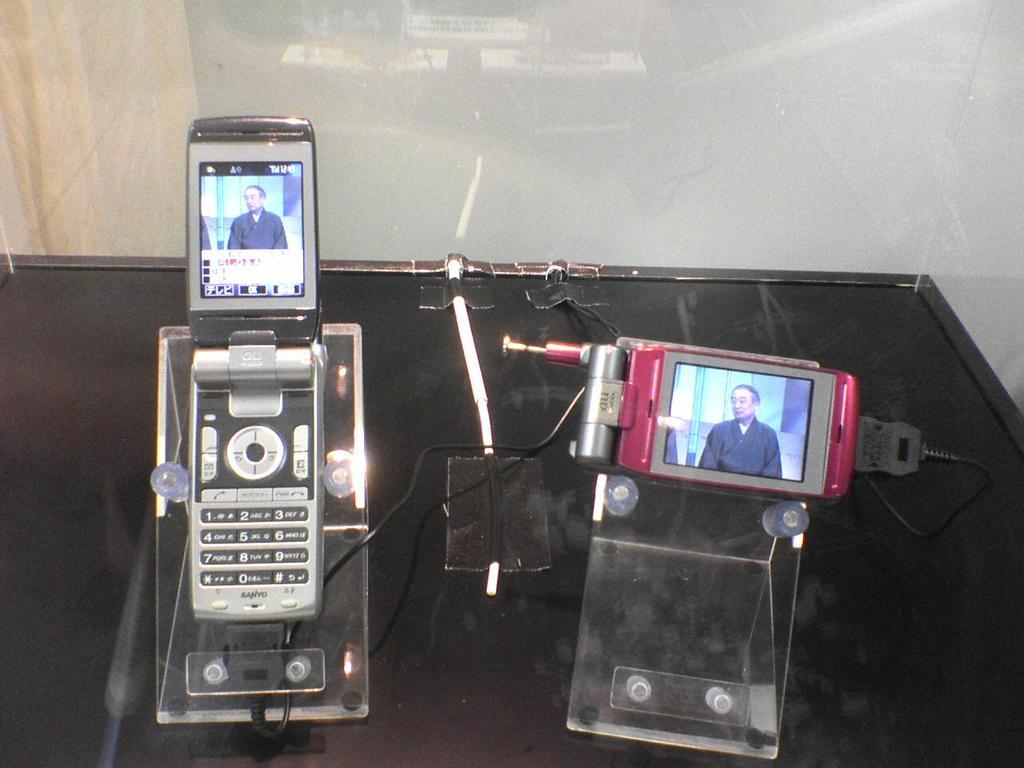What objects can be seen in the image? There are mobiles, stands, and cables on the table in the image. What is the purpose of the stands in the image? The purpose of the stands is not explicitly stated, but they may be used to support or display the mobiles. What is the appearance of the background in the image? There is a sheet in the background of the image. What type of cables are visible on the table? The specific type of cables is not mentioned, but they are likely related to the mobiles or stands. Is there an actor performing on the sheet in the background of the image? No, there is no actor or performance depicted in the image; it primarily features mobiles, stands, and cables on a table. 